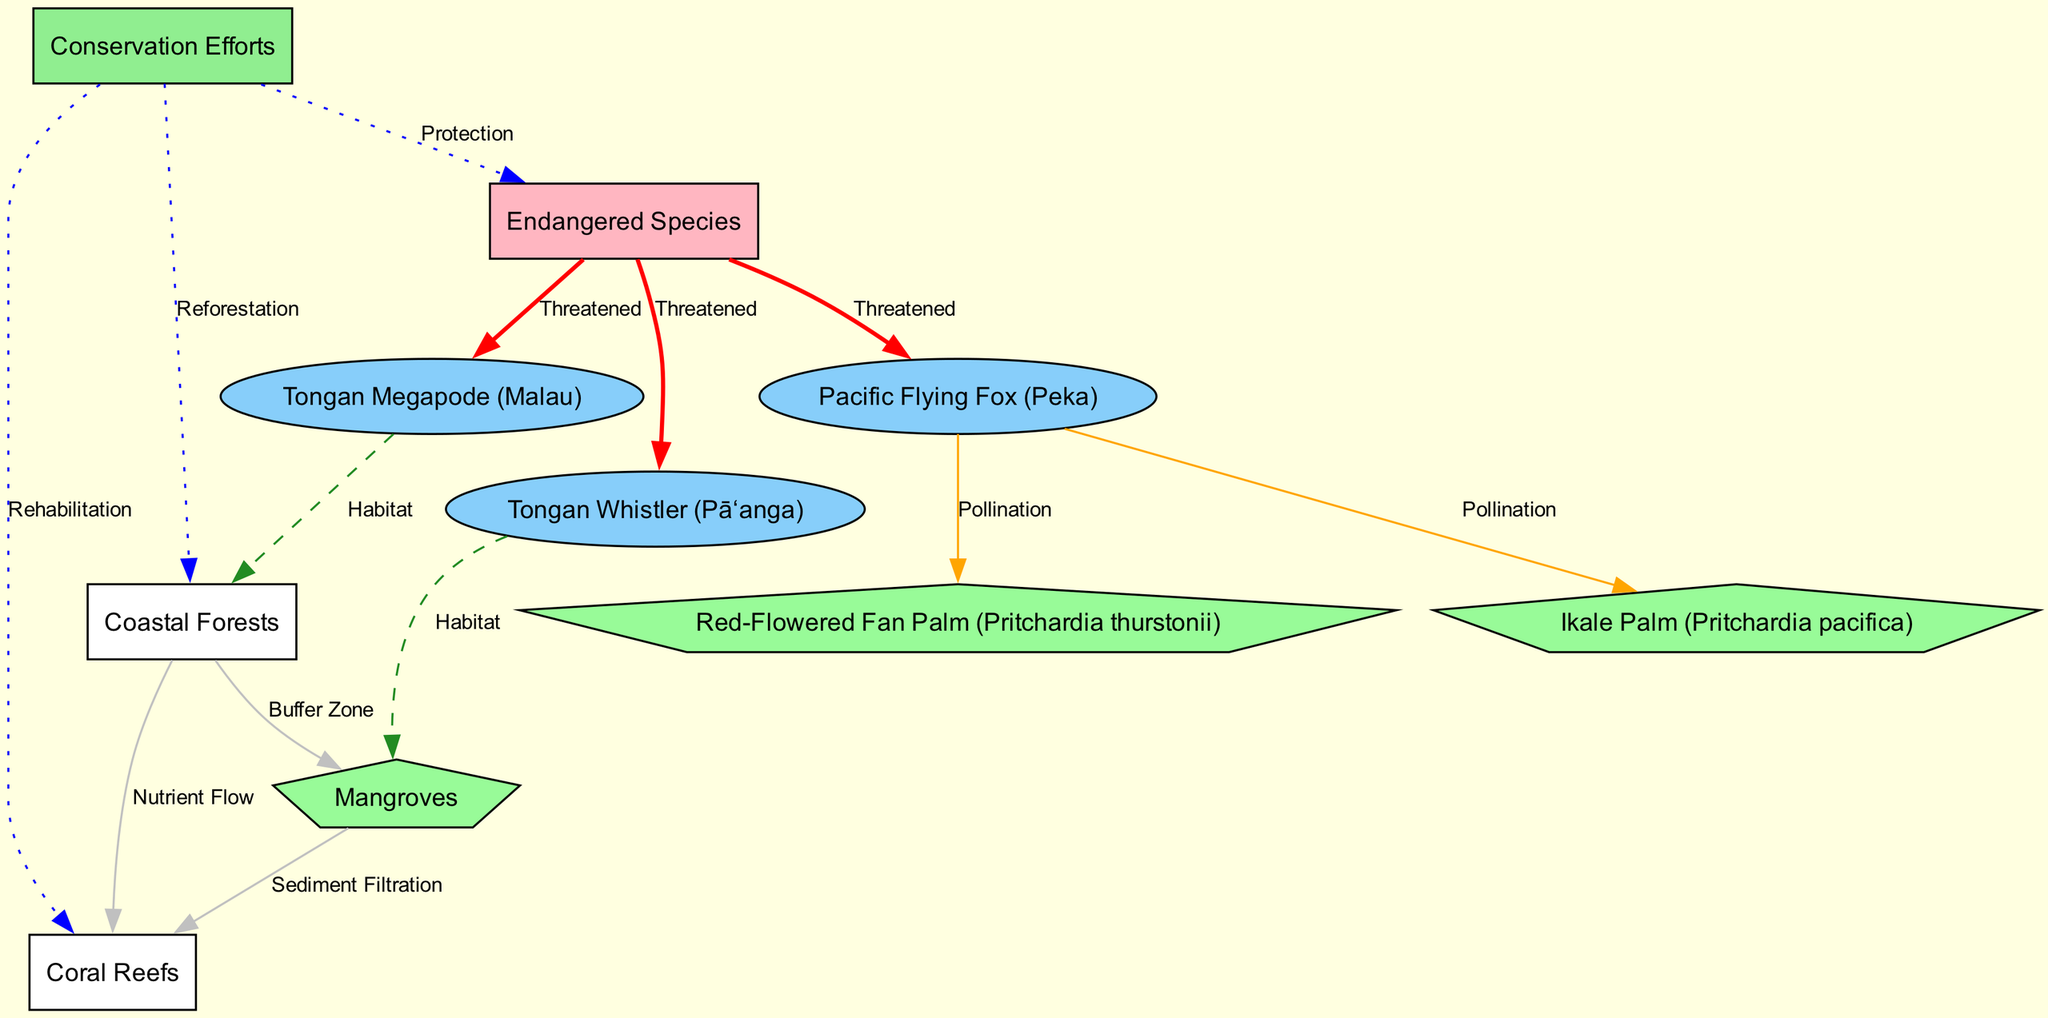What is the habitat of the Tongan Megapode? The Tongan Megapode is connected to the Coastal Forest node through a dashed edge labeled "Habitat," indicating that Coastal Forests provide the habitat for this bird species.
Answer: Coastal Forests How many endangered species are highlighted in the diagram? The diagram connects three species (Tongan Megapode, Pacific Flying Fox, and Tongan Whistler) to the Endangered Species node with edges labeled "Threatened," which indicates there are three endangered species shown.
Answer: 3 Which species is involved in the pollination of the Ikale Palm? The Flying Fox is marked as connecting to the Ikale Palm with an edge labeled "Pollination," indicating that the Flying Fox is responsible for pollinating this species.
Answer: Flying Fox What role do Mangroves play in relation to Coral Reefs? The diagram shows a connection from Mangrove to Coral Reefs labeled "Sediment Filtration," meaning that Mangroves contribute by filtering sediments that can affect Coral Reef health.
Answer: Sediment Filtration How does Coastal Forest contribute to Coral Reefs? The Coastal Forest is connected to Coral Reefs with an edge labeled "Nutrient Flow," indicating that it plays a role in transferring nutrients to support Coral Reef ecosystems.
Answer: Nutrient Flow What conservation effort is associated with the protection of endangered species? The diagram links Conservation Efforts to Endangered Species through an edge labeled "Protection," indicating that these efforts are geared towards protecting the endangered species depicted in the diagram.
Answer: Protection Which two species are connected to the Red-Flowered Fan Palm for pollination? The Flying Fox is shown to pollinate both the Red-Flowered Fan Palm and Ikale Palm, meaning these are the two species connected to this particular plant for pollination.
Answer: Flying Fox and Ikale Palm What is the purpose of the connection between Coastal Forests and Mangroves? The diagram shows a connection labeled "Buffer Zone" between Coastal Forests and Mangroves, indicating a supportive ecological relationship that helps protect both habitats from external effects.
Answer: Buffer Zone Which type of ecosystem is depicted as a nutrient source for Coral Reefs in the diagram? Coastal Forests have a direct connection labeled "Nutrient Flow" to Coral Reefs, indicating that Coastal Forests serve as a nutrient source for this marine ecosystem.
Answer: Coastal Forests 